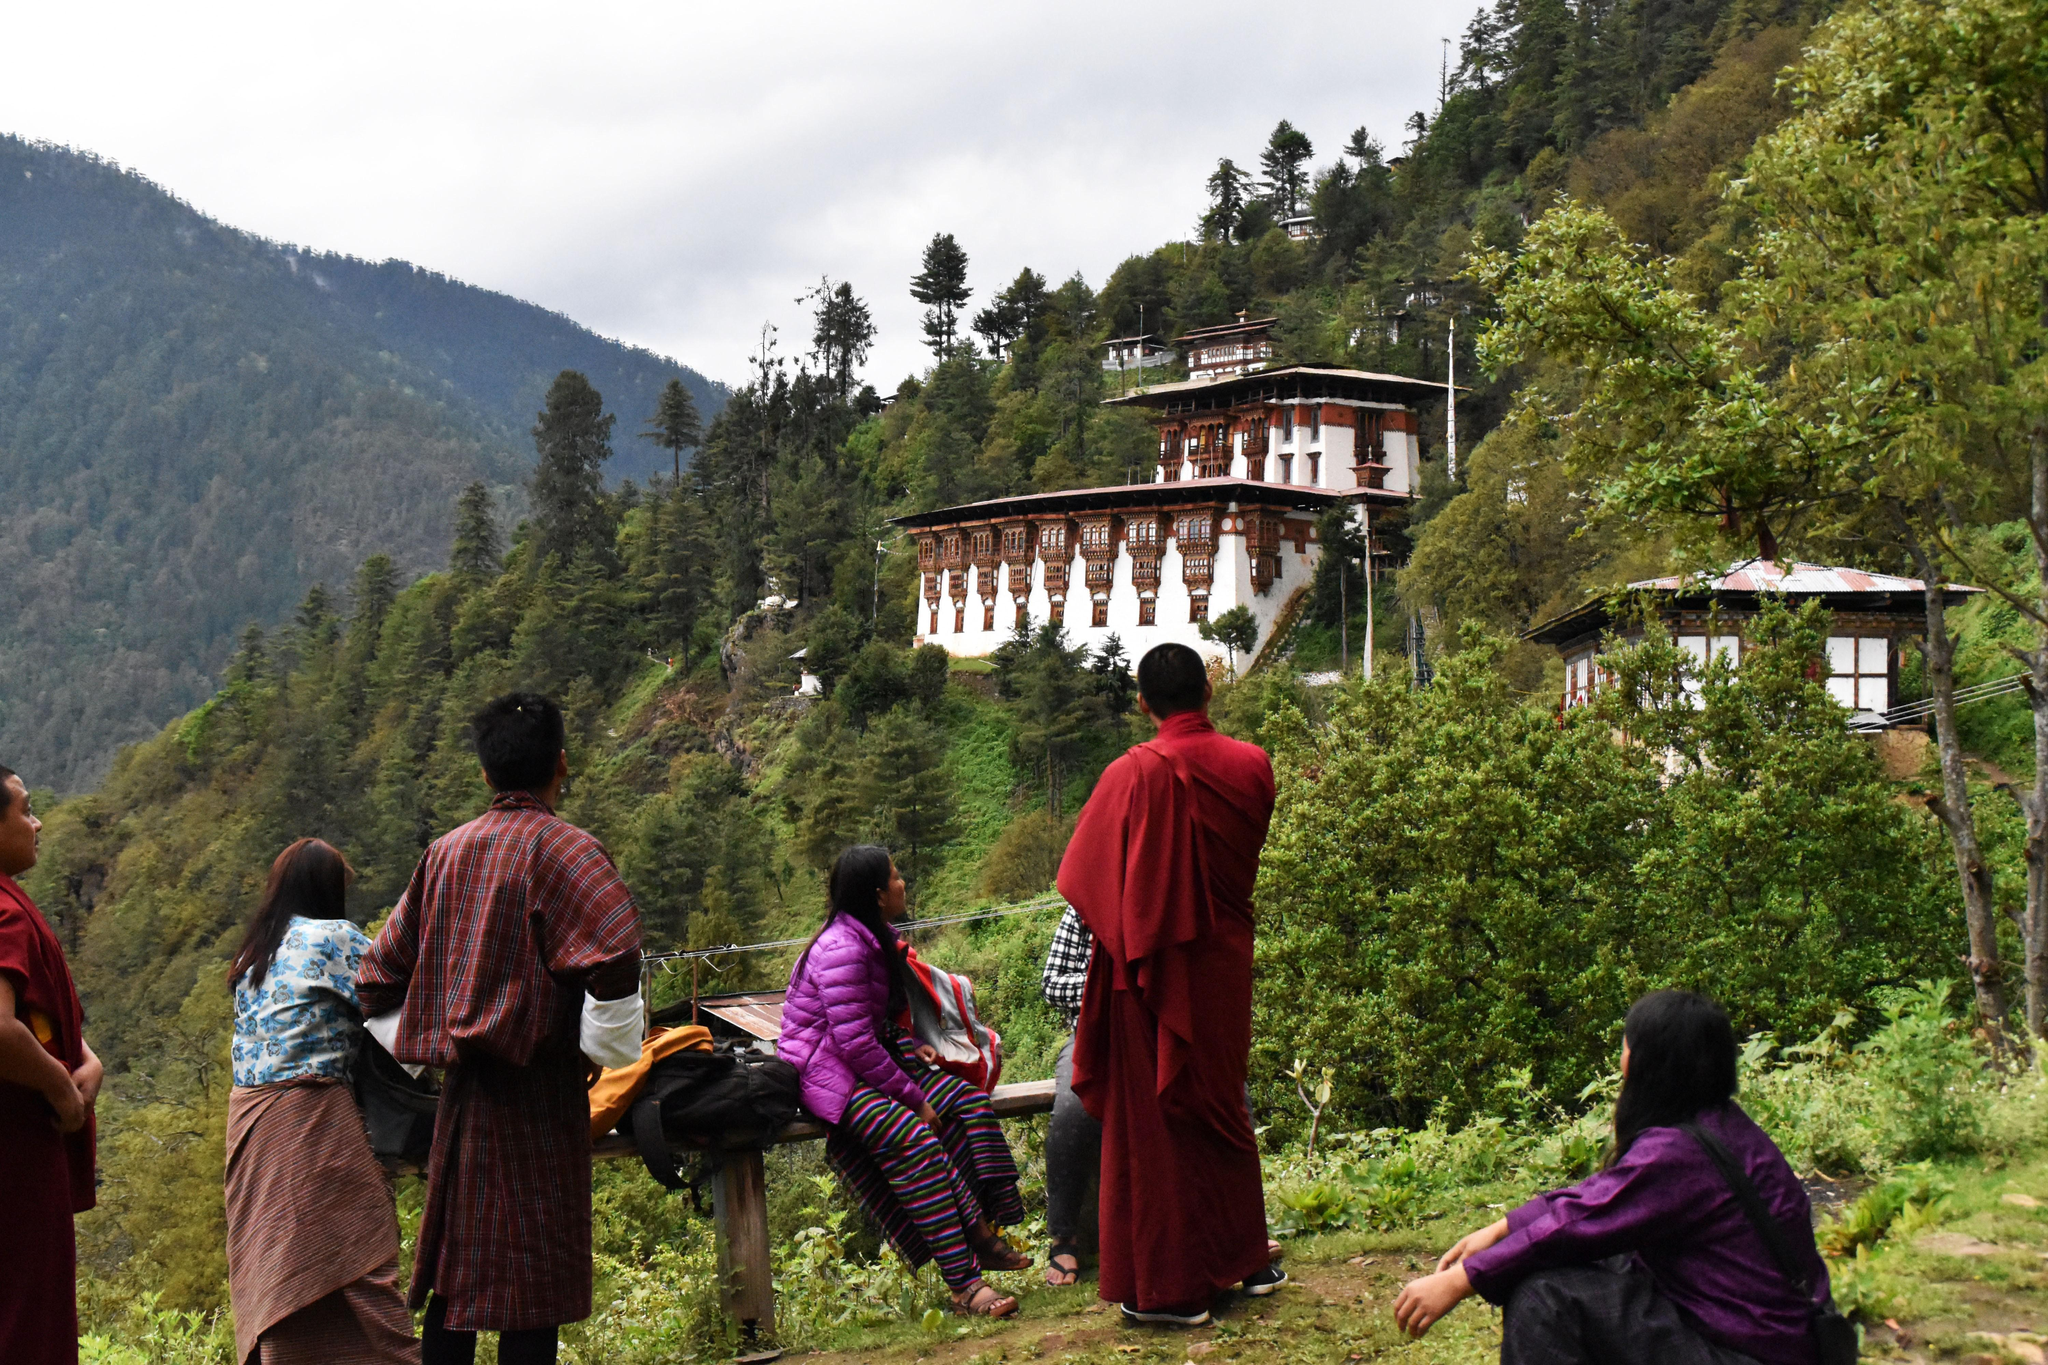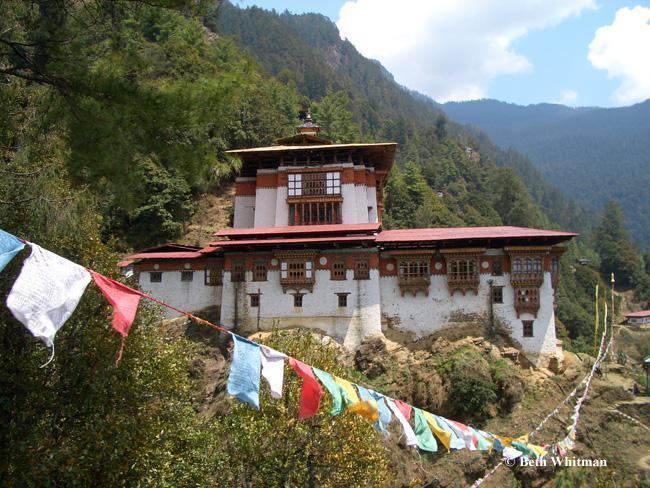The first image is the image on the left, the second image is the image on the right. Evaluate the accuracy of this statement regarding the images: "In at least one image there are people outside of a monastery.". Is it true? Answer yes or no. Yes. The first image is the image on the left, the second image is the image on the right. Assess this claim about the two images: "blue sky can be seen in the right pic". Correct or not? Answer yes or no. Yes. The first image is the image on the left, the second image is the image on the right. Analyze the images presented: Is the assertion "An image shows multiple people in front of a hillside building." valid? Answer yes or no. Yes. The first image is the image on the left, the second image is the image on the right. Analyze the images presented: Is the assertion "In one of the images there is more than one person." valid? Answer yes or no. Yes. 